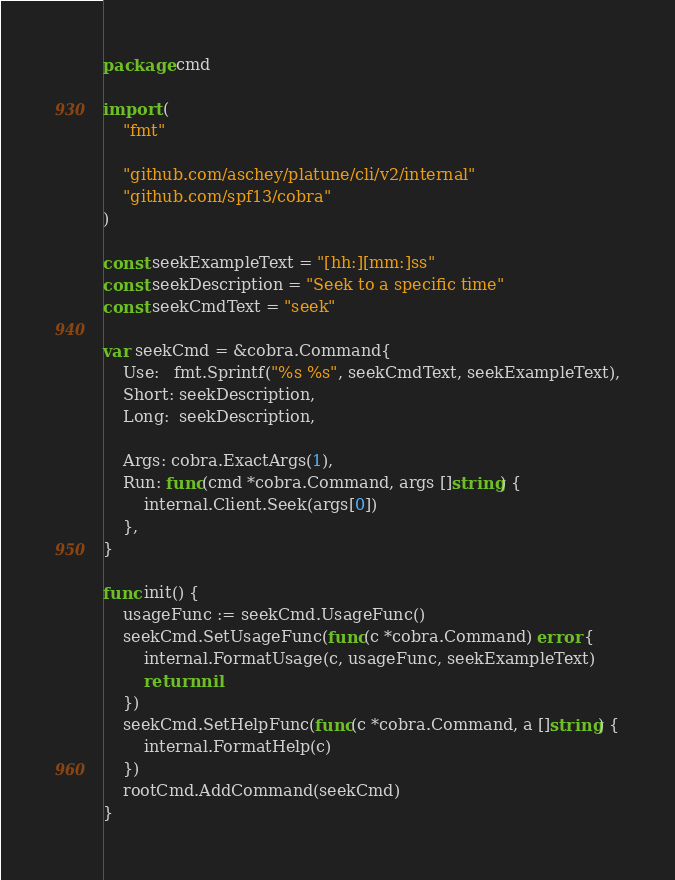Convert code to text. <code><loc_0><loc_0><loc_500><loc_500><_Go_>package cmd

import (
	"fmt"

	"github.com/aschey/platune/cli/v2/internal"
	"github.com/spf13/cobra"
)

const seekExampleText = "[hh:][mm:]ss"
const seekDescription = "Seek to a specific time"
const seekCmdText = "seek"

var seekCmd = &cobra.Command{
	Use:   fmt.Sprintf("%s %s", seekCmdText, seekExampleText),
	Short: seekDescription,
	Long:  seekDescription,

	Args: cobra.ExactArgs(1),
	Run: func(cmd *cobra.Command, args []string) {
		internal.Client.Seek(args[0])
	},
}

func init() {
	usageFunc := seekCmd.UsageFunc()
	seekCmd.SetUsageFunc(func(c *cobra.Command) error {
		internal.FormatUsage(c, usageFunc, seekExampleText)
		return nil
	})
	seekCmd.SetHelpFunc(func(c *cobra.Command, a []string) {
		internal.FormatHelp(c)
	})
	rootCmd.AddCommand(seekCmd)
}
</code> 